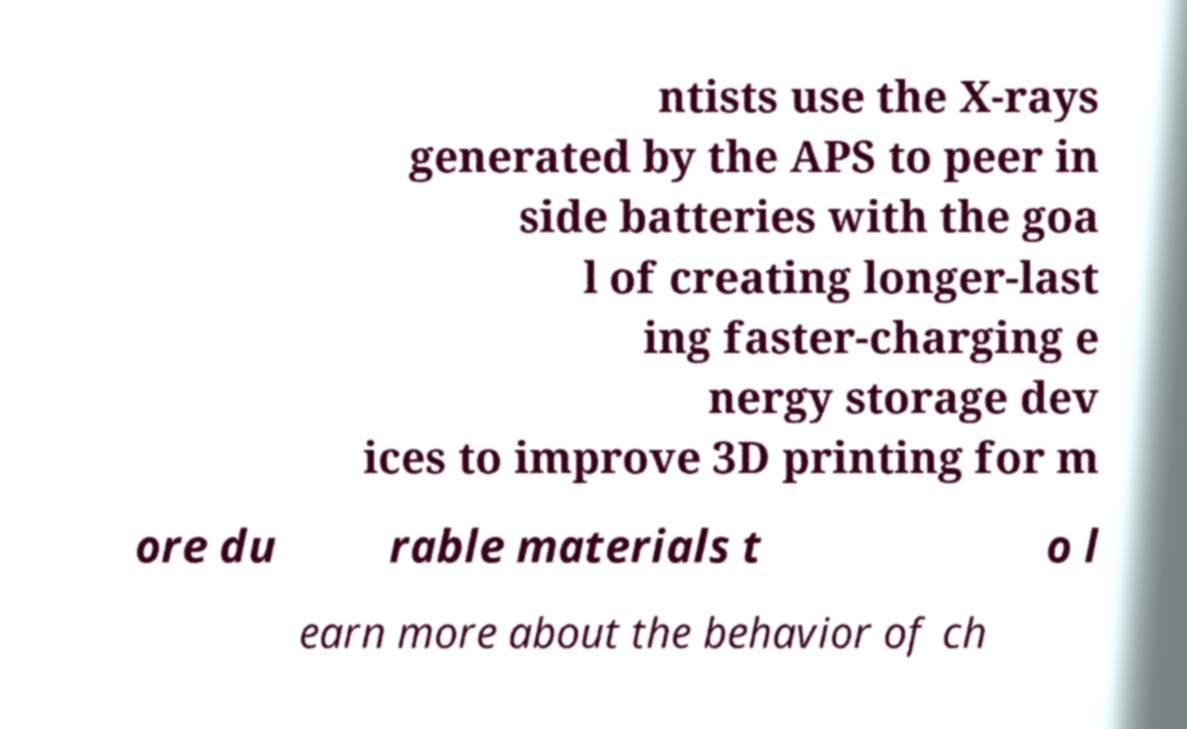Could you assist in decoding the text presented in this image and type it out clearly? ntists use the X-rays generated by the APS to peer in side batteries with the goa l of creating longer-last ing faster-charging e nergy storage dev ices to improve 3D printing for m ore du rable materials t o l earn more about the behavior of ch 